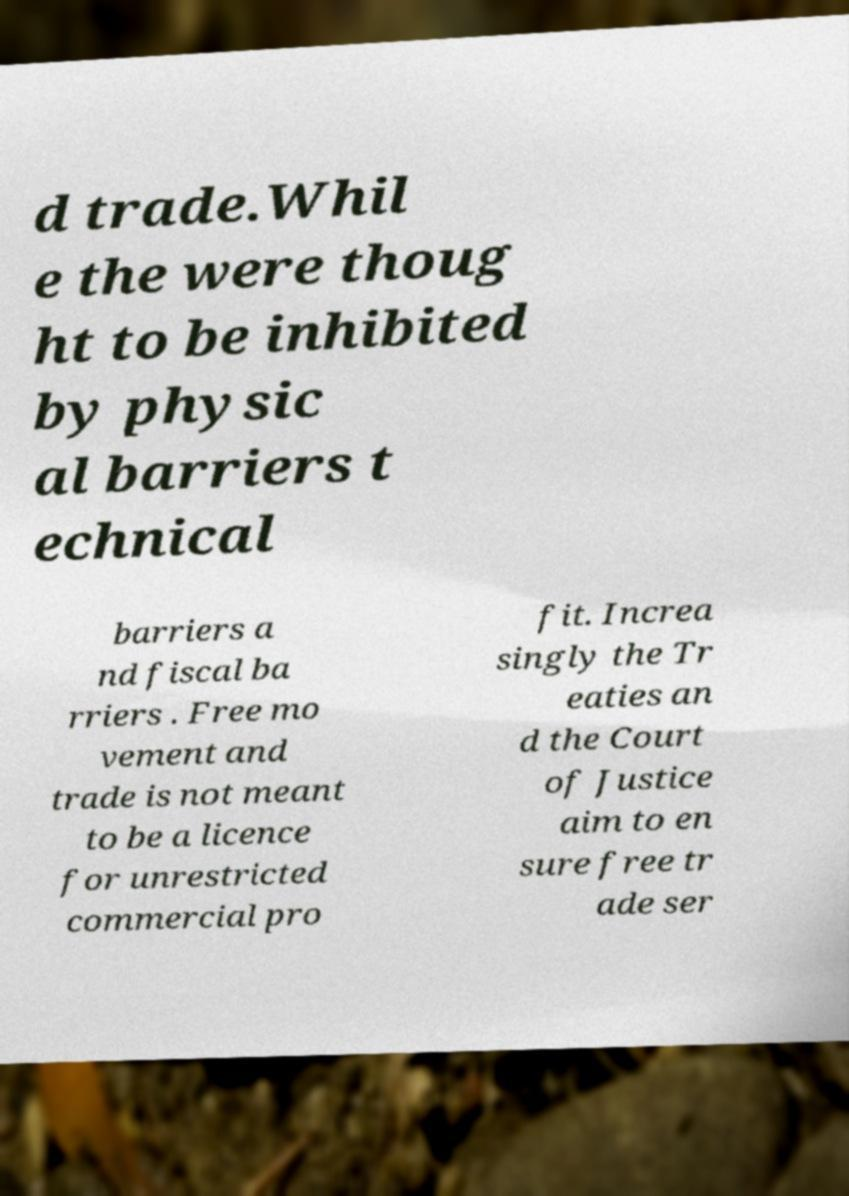There's text embedded in this image that I need extracted. Can you transcribe it verbatim? d trade.Whil e the were thoug ht to be inhibited by physic al barriers t echnical barriers a nd fiscal ba rriers . Free mo vement and trade is not meant to be a licence for unrestricted commercial pro fit. Increa singly the Tr eaties an d the Court of Justice aim to en sure free tr ade ser 